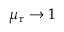Convert formula to latex. <formula><loc_0><loc_0><loc_500><loc_500>\mu _ { r } \rightarrow 1</formula> 